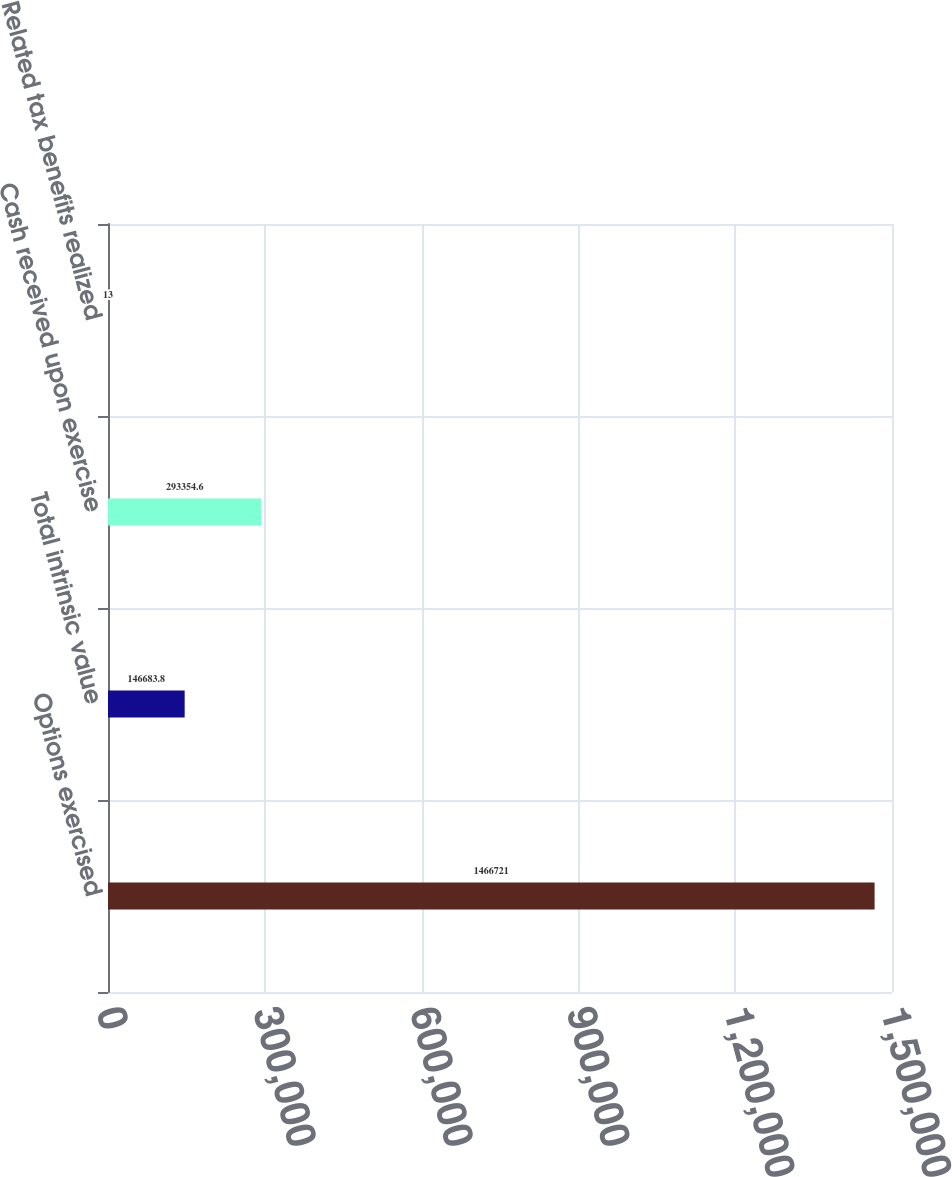<chart> <loc_0><loc_0><loc_500><loc_500><bar_chart><fcel>Options exercised<fcel>Total intrinsic value<fcel>Cash received upon exercise<fcel>Related tax benefits realized<nl><fcel>1.46672e+06<fcel>146684<fcel>293355<fcel>13<nl></chart> 